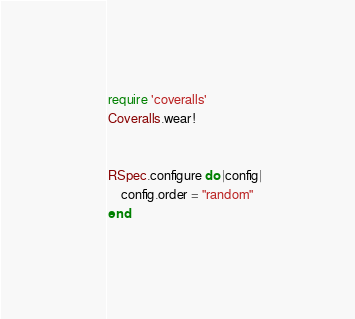Convert code to text. <code><loc_0><loc_0><loc_500><loc_500><_Ruby_>
require 'coveralls'
Coveralls.wear!


RSpec.configure do |config|
	config.order = "random"
end

</code> 